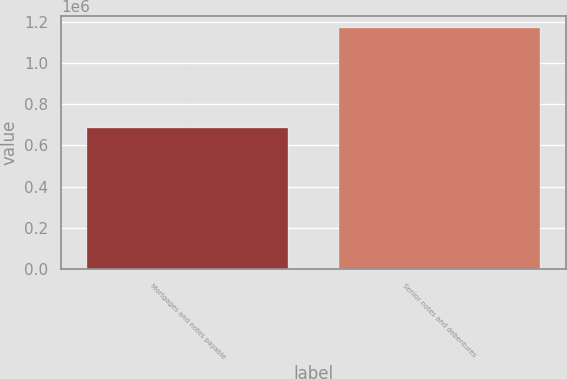Convert chart. <chart><loc_0><loc_0><loc_500><loc_500><bar_chart><fcel>Mortgages and notes payable<fcel>Senior notes and debentures<nl><fcel>685552<fcel>1.16868e+06<nl></chart> 